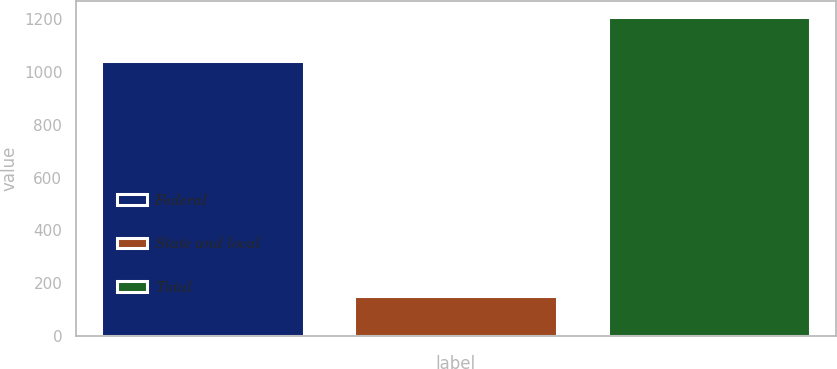Convert chart. <chart><loc_0><loc_0><loc_500><loc_500><bar_chart><fcel>Federal<fcel>State and local<fcel>Total<nl><fcel>1040<fcel>152<fcel>1207<nl></chart> 